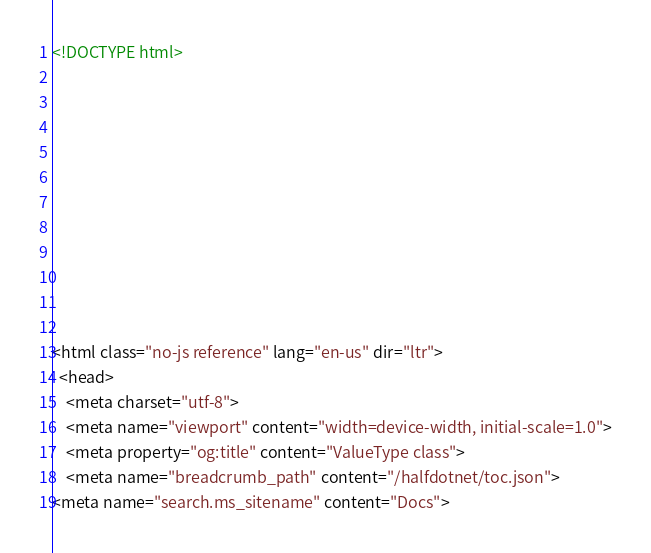Convert code to text. <code><loc_0><loc_0><loc_500><loc_500><_HTML_><!DOCTYPE html>



  


  


  

<html class="no-js reference" lang="en-us" dir="ltr">
  <head>
    <meta charset="utf-8">
    <meta name="viewport" content="width=device-width, initial-scale=1.0">
    <meta property="og:title" content="ValueType class">
    <meta name="breadcrumb_path" content="/halfdotnet/toc.json">
<meta name="search.ms_sitename" content="Docs"></code> 